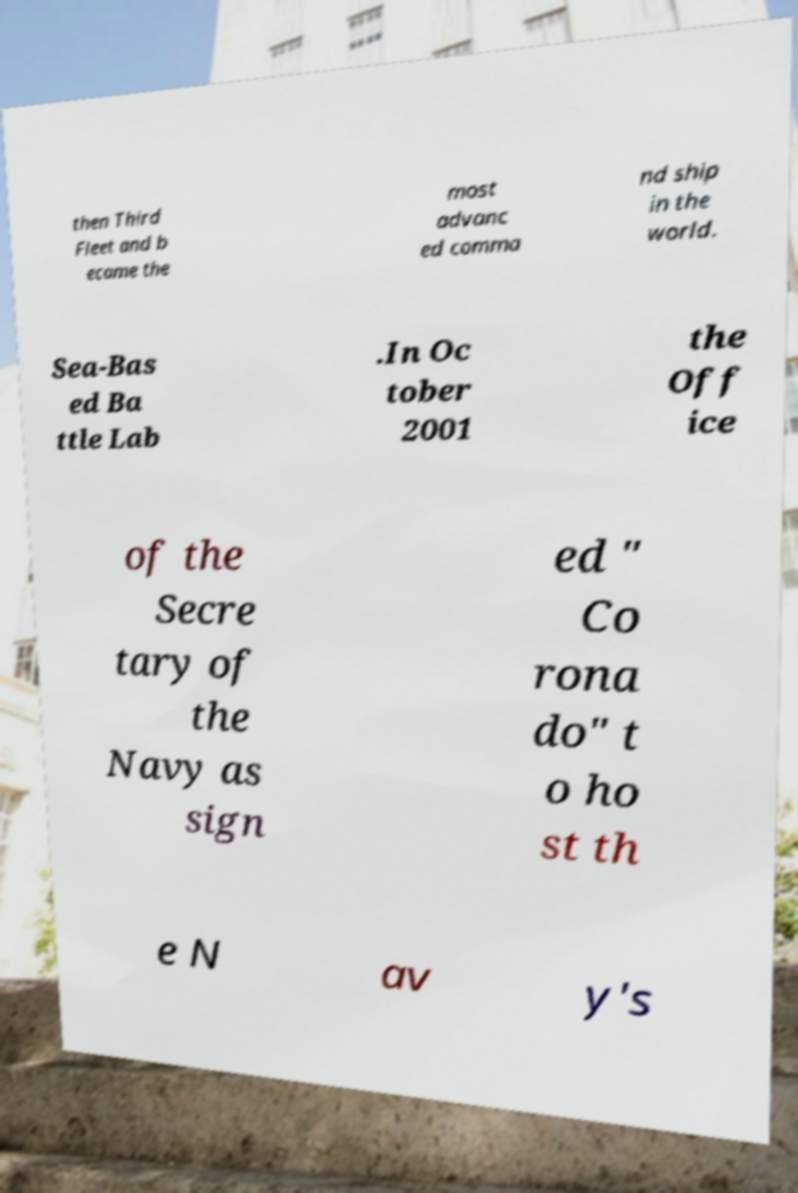There's text embedded in this image that I need extracted. Can you transcribe it verbatim? then Third Fleet and b ecame the most advanc ed comma nd ship in the world. Sea-Bas ed Ba ttle Lab .In Oc tober 2001 the Off ice of the Secre tary of the Navy as sign ed " Co rona do" t o ho st th e N av y's 